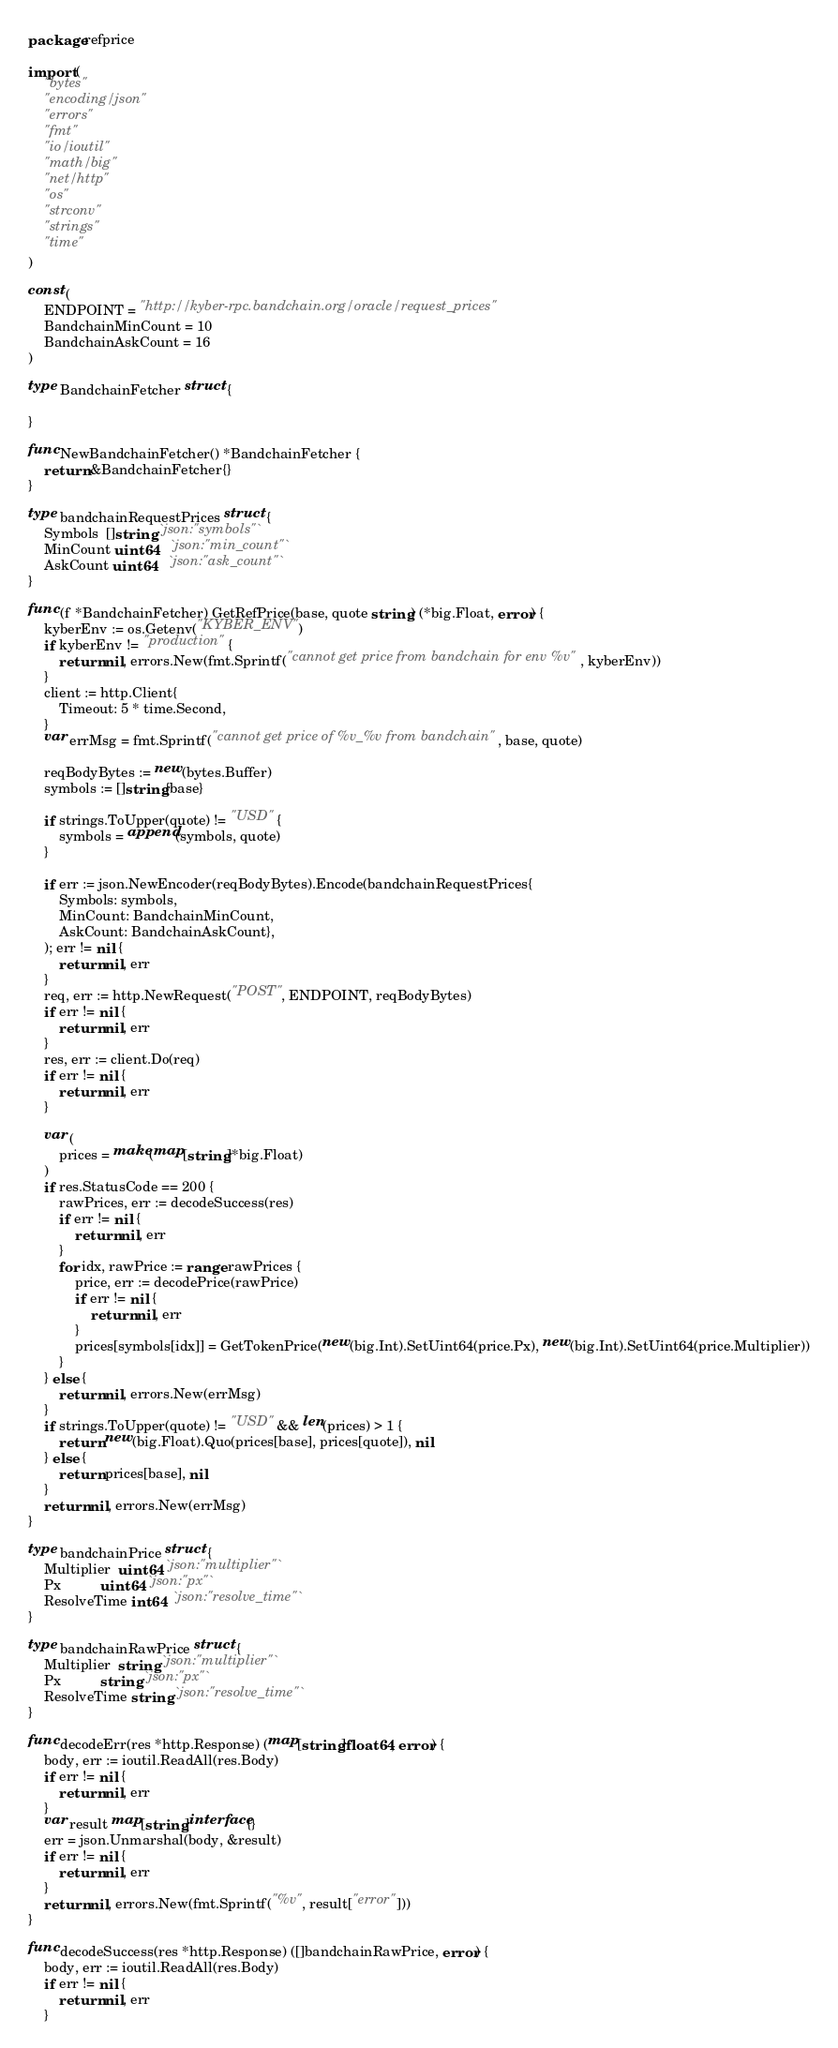Convert code to text. <code><loc_0><loc_0><loc_500><loc_500><_Go_>package refprice

import (
	"bytes"
	"encoding/json"
	"errors"
	"fmt"
	"io/ioutil"
	"math/big"
	"net/http"
	"os"
	"strconv"
	"strings"
	"time"
)

const (
	ENDPOINT = "http://kyber-rpc.bandchain.org/oracle/request_prices"
	BandchainMinCount = 10
	BandchainAskCount = 16
)

type BandchainFetcher struct {

}

func NewBandchainFetcher() *BandchainFetcher {
	return &BandchainFetcher{}
}

type bandchainRequestPrices struct {
	Symbols  []string `json:"symbols"`
	MinCount uint64   `json:"min_count"`
	AskCount uint64   `json:"ask_count"`
}

func (f *BandchainFetcher) GetRefPrice(base, quote string) (*big.Float, error) {
	kyberEnv := os.Getenv("KYBER_ENV")
	if kyberEnv != "production" {
		return nil, errors.New(fmt.Sprintf("cannot get price from bandchain for env %v", kyberEnv))
	}
	client := http.Client{
		Timeout: 5 * time.Second,
	}
	var errMsg = fmt.Sprintf("cannot get price of %v_%v from bandchain", base, quote)

	reqBodyBytes := new(bytes.Buffer)
	symbols := []string{base}

	if strings.ToUpper(quote) != "USD" {
		symbols = append(symbols, quote)
	}

	if err := json.NewEncoder(reqBodyBytes).Encode(bandchainRequestPrices{
		Symbols: symbols,
		MinCount: BandchainMinCount,
		AskCount: BandchainAskCount},
	); err != nil {
		return nil, err
	}
	req, err := http.NewRequest("POST", ENDPOINT, reqBodyBytes)
	if err != nil {
		return nil, err
	}
	res, err := client.Do(req)
	if err != nil {
		return nil, err
	}

	var (
		prices = make(map[string]*big.Float)
	)
	if res.StatusCode == 200 {
		rawPrices, err := decodeSuccess(res)
		if err != nil {
			return nil, err
		}
		for idx, rawPrice := range rawPrices {
			price, err := decodePrice(rawPrice)
			if err != nil {
				return nil, err
			}
			prices[symbols[idx]] = GetTokenPrice(new(big.Int).SetUint64(price.Px), new(big.Int).SetUint64(price.Multiplier))
		}
	} else {
		return nil, errors.New(errMsg)
	}
	if strings.ToUpper(quote) != "USD" && len(prices) > 1 {
		return new(big.Float).Quo(prices[base], prices[quote]), nil
	} else {
		return prices[base], nil
	}
	return nil, errors.New(errMsg)
}

type bandchainPrice struct {
	Multiplier  uint64 `json:"multiplier"`
	Px          uint64 `json:"px"`
	ResolveTime int64  `json:"resolve_time"`
}

type bandchainRawPrice struct {
	Multiplier  string `json:"multiplier"`
	Px          string `json:"px"`
	ResolveTime string `json:"resolve_time"`
}

func decodeErr(res *http.Response) (map[string]float64, error) {
	body, err := ioutil.ReadAll(res.Body)
	if err != nil {
		return nil, err
	}
	var result map[string]interface{}
	err = json.Unmarshal(body, &result)
	if err != nil {
		return nil, err
	}
	return nil, errors.New(fmt.Sprintf("%v", result["error"]))
}

func decodeSuccess(res *http.Response) ([]bandchainRawPrice, error) {
	body, err := ioutil.ReadAll(res.Body)
	if err != nil {
		return nil, err
	}</code> 